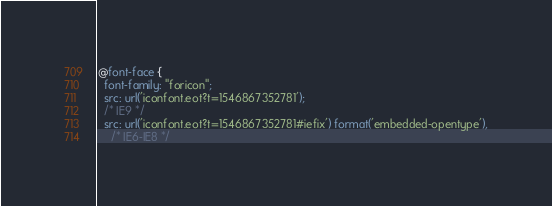<code> <loc_0><loc_0><loc_500><loc_500><_CSS_>@font-face {
  font-family: "foricon";
  src: url('iconfont.eot?t=1546867352781');
  /* IE9 */
  src: url('iconfont.eot?t=1546867352781#iefix') format('embedded-opentype'),
    /* IE6-IE8 */</code> 